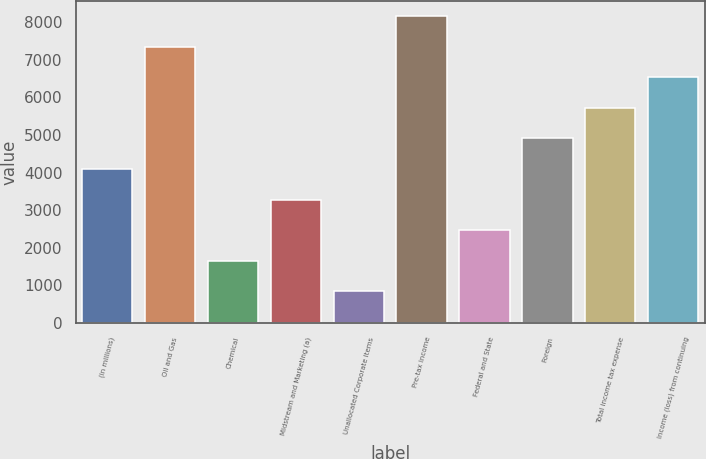Convert chart to OTSL. <chart><loc_0><loc_0><loc_500><loc_500><bar_chart><fcel>(in millions)<fcel>Oil and Gas<fcel>Chemical<fcel>Midstream and Marketing (a)<fcel>Unallocated Corporate Items<fcel>Pre-tax income<fcel>Federal and State<fcel>Foreign<fcel>Total income tax expense<fcel>Income (loss) from continuing<nl><fcel>4093<fcel>7335.4<fcel>1661.2<fcel>3282.4<fcel>850.6<fcel>8146<fcel>2471.8<fcel>4903.6<fcel>5714.2<fcel>6524.8<nl></chart> 